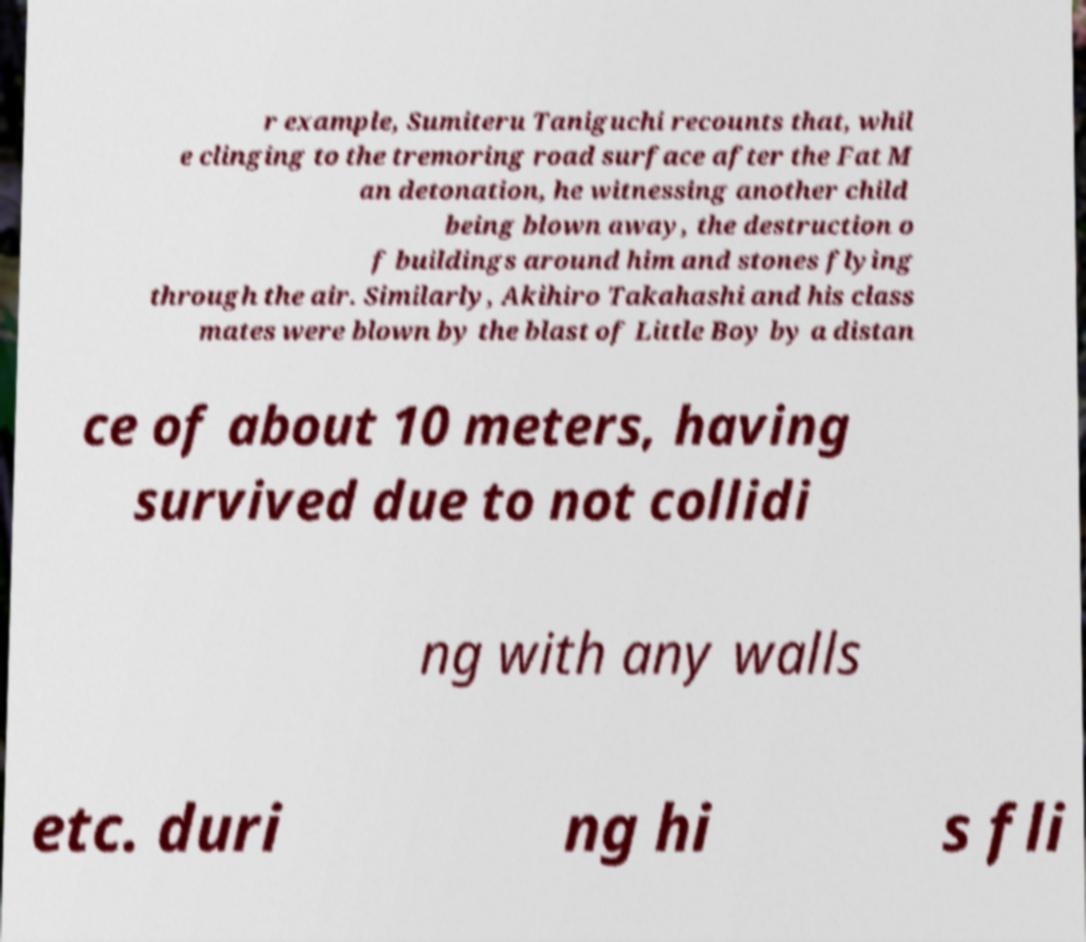Could you assist in decoding the text presented in this image and type it out clearly? r example, Sumiteru Taniguchi recounts that, whil e clinging to the tremoring road surface after the Fat M an detonation, he witnessing another child being blown away, the destruction o f buildings around him and stones flying through the air. Similarly, Akihiro Takahashi and his class mates were blown by the blast of Little Boy by a distan ce of about 10 meters, having survived due to not collidi ng with any walls etc. duri ng hi s fli 